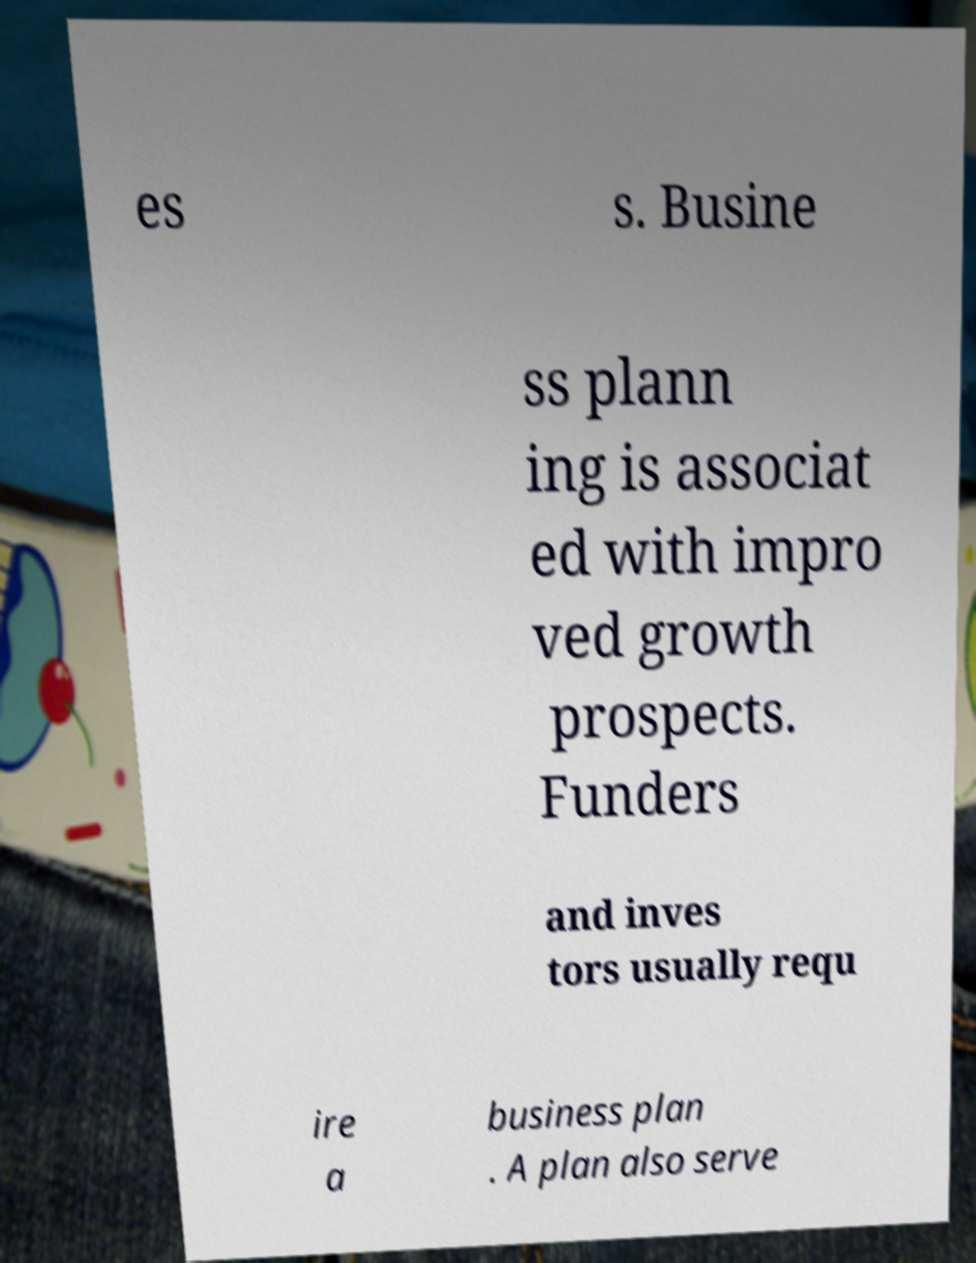Could you extract and type out the text from this image? es s. Busine ss plann ing is associat ed with impro ved growth prospects. Funders and inves tors usually requ ire a business plan . A plan also serve 